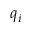<formula> <loc_0><loc_0><loc_500><loc_500>q _ { i }</formula> 